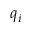<formula> <loc_0><loc_0><loc_500><loc_500>q _ { i }</formula> 